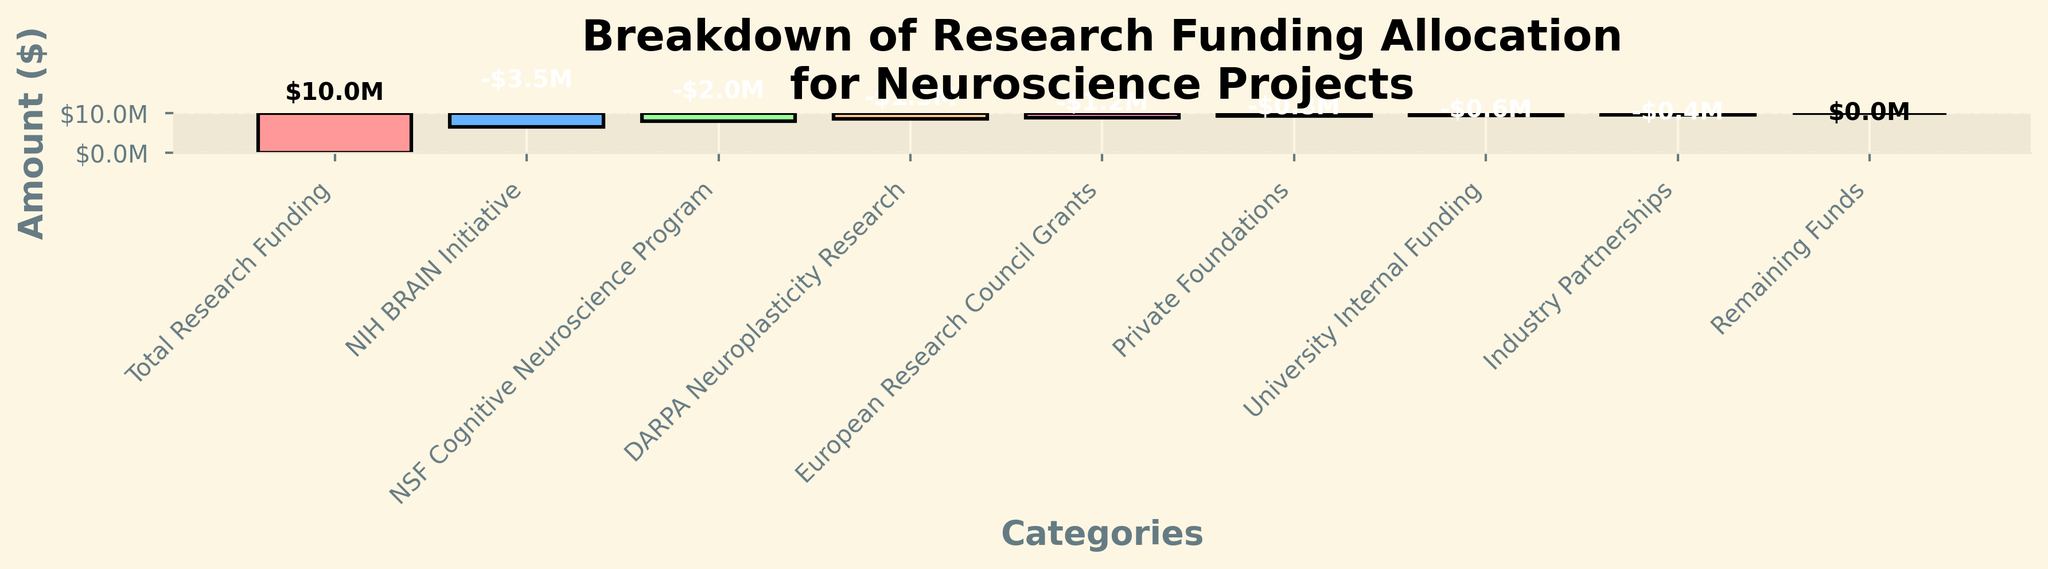What is the total amount of research funding allocated to neuroscience projects? According to the figure, the total research funding allocation is shown as the first bar in the waterfall chart.
Answer: $10M Which source provides the highest funding for neuroscience projects? The NIH BRAIN Initiative provides the highest funding, which can be identified as the next significant drop after the total research funding.
Answer: NIH BRAIN Initiative What is the remaining amount of funding after all allocations? The last bar in the waterfall chart shows the remaining funds, which according to the figure is $0 as it's the neutral point at the end of the allocations.
Answer: $0 How much funding is allocated by the University for internal research? The University Internal Funding amount is shown in the figure with a dedicated bar.
Answer: $0.6M What is the difference in funding between the NIH BRAIN Initiative and NSF Cognitive Neuroscience Program? The NIH BRAIN Initiative allocated $3.5M, and the NSF Cognitive Neuroscience Program allocated $2M, thus the difference is $3.5M - $2M = $1.5M.
Answer: $1.5M What are the amounts allocated by private foundations and industry partnerships combined? Private Foundations allocated $0.8M and Industry Partnerships allocated $0.4M, so the combined allocation is $0.8M + $0.4M = $1.2M.
Answer: $1.2M Which funding source contributes less, DARPA Neuroplasticity Research or European Research Council Grants? By comparing their respective bars, DARPA Neuroplasticity Research allocated $1.5M whereas European Research Council Grants allocated $1.2M. Since $1.2M is less than $1.5M, the European Research Council Grants contributes less.
Answer: European Research Council Grants How much funding in total is provided by government initiatives (NIH, NSF, and DARPA)? The NIH BRAIN Initiative allocated $3.5M, NSF Cognitive Neuroscience Program allocated $2M, and DARPA Neuroplasticity Research allocated $1.5M. The total is $3.5M + $2M + $1.5M = $7M.
Answer: $7M If private foundations increased their funding by $200,000, what would be the new total private foundation funding amount? Currently, private foundations allocate $0.8M. With an increase of $200,000, the new funding amount would be $0.8M + $0.2M = $1M.
Answer: $1M 